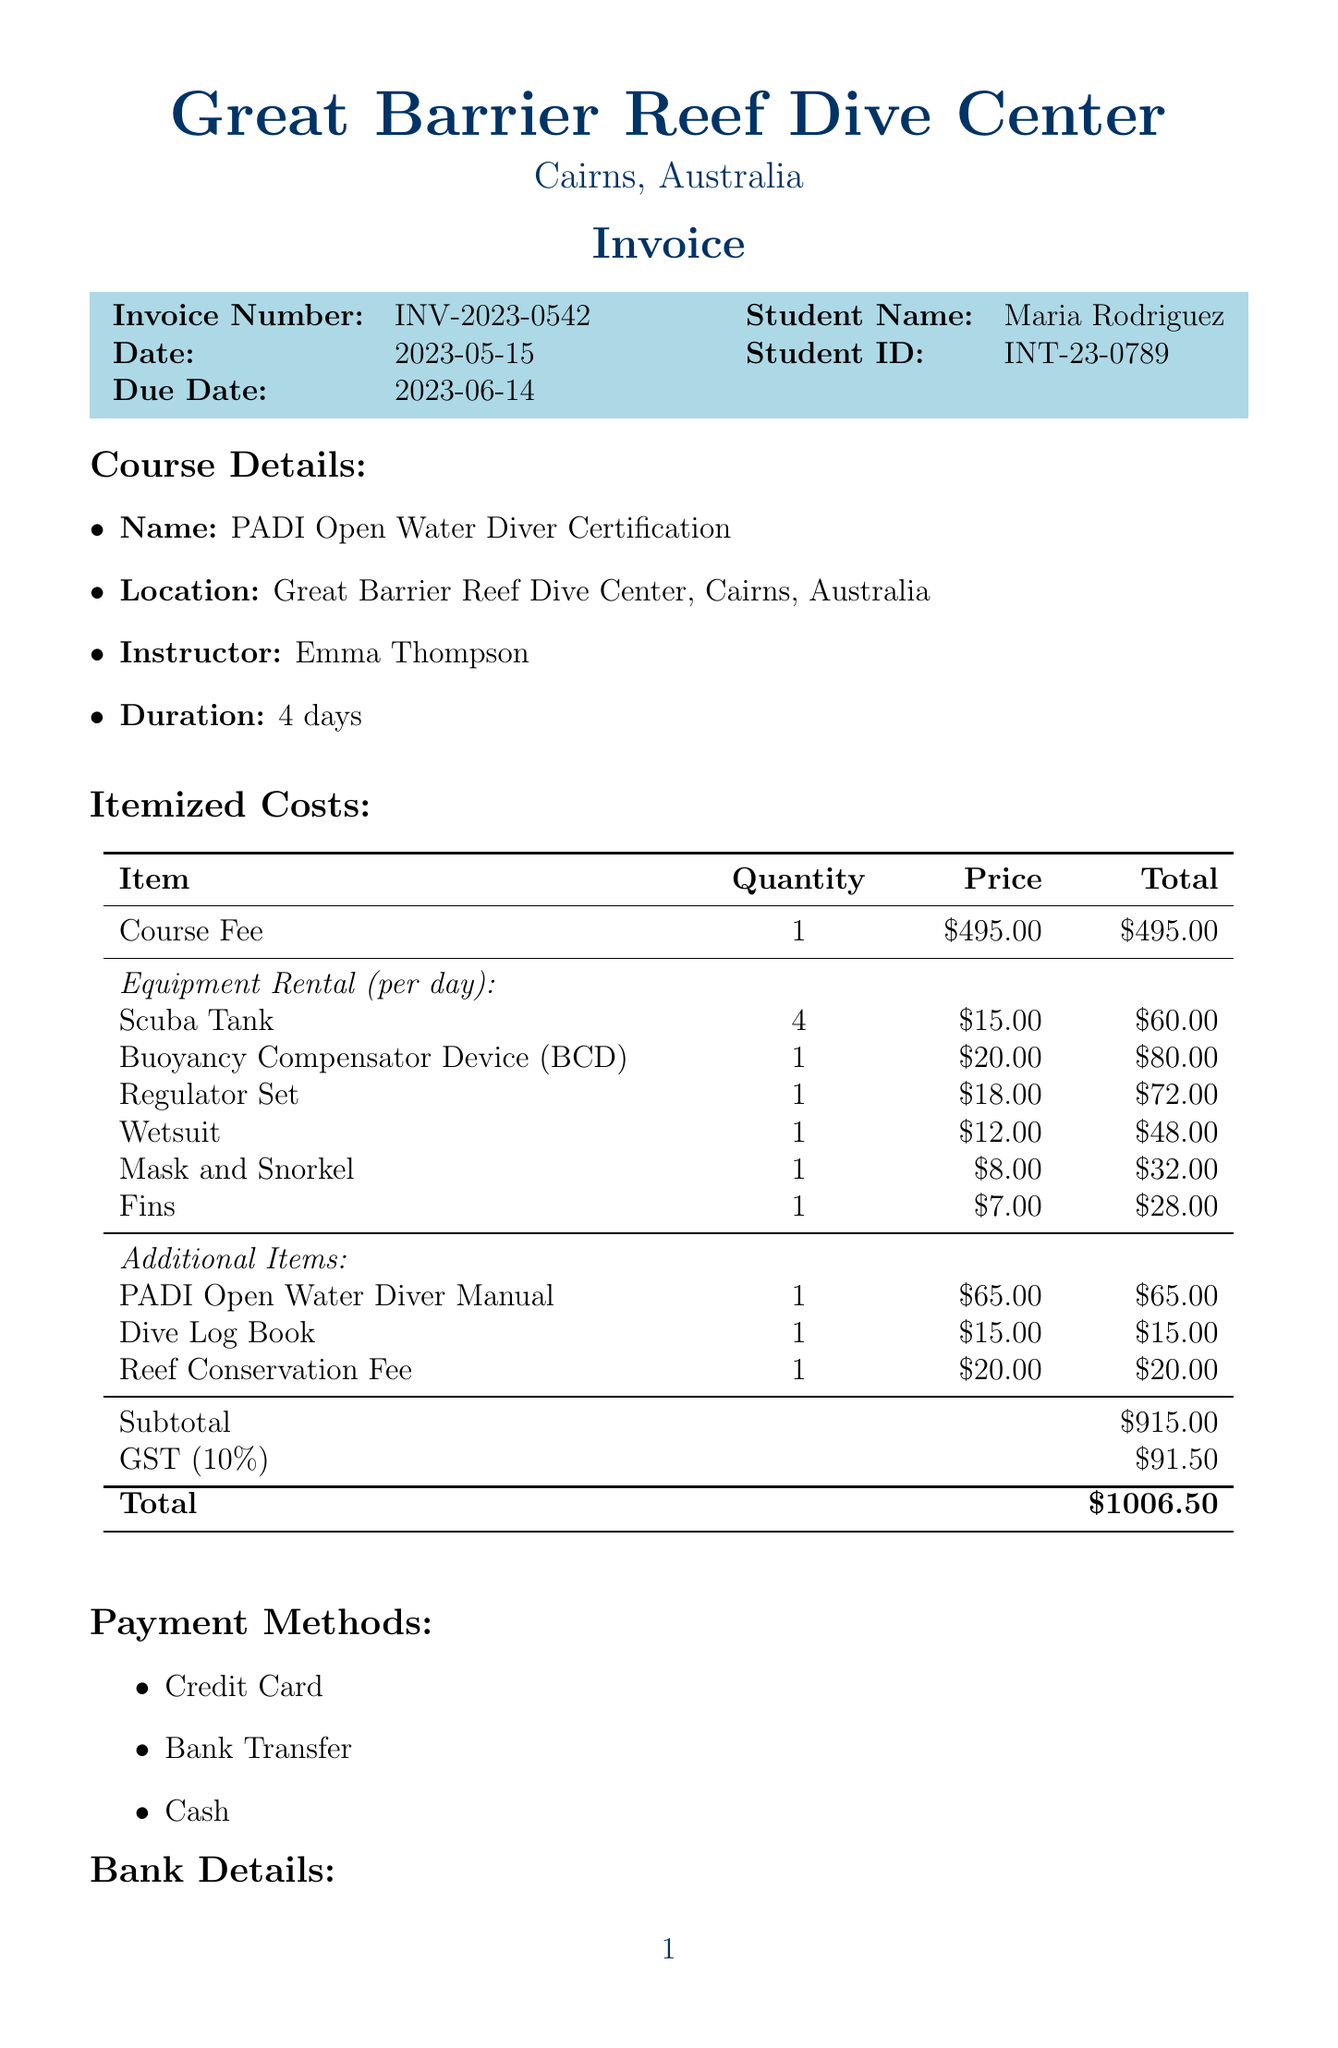What is the invoice number? The invoice number is specifically provided in the document as a reference for the transaction.
Answer: INV-2023-0542 Who is the instructor for the course? The instructor's name is mentioned in the course details section of the document.
Answer: Emma Thompson What is the total amount due? The total amount due is calculated and presented at the bottom of the invoice.
Answer: $1006.50 What is the cost of renting a Wetsuit? The document lists the price for the Wetsuit rental among the equipment rental costs.
Answer: $48.00 How many days does the course last? The duration of the course is specified in the course details section of the document.
Answer: 4 days What item has the highest rental cost? The reasoning involves comparing the total costs for each rented item mentioned in the document.
Answer: Buoyancy Compensator Device (BCD) What payment methods are accepted? The document explicitly lists the payment methods available for settling the invoice.
Answer: Credit Card, Bank Transfer, Cash What additional item costs $20.00? The document lists various additional items along with their respective prices.
Answer: Reef Conservation Fee What is the subtotal before tax? The subtotal is calculated as all the itemized costs excluding the GST presented in the invoice.
Answer: $915.00 